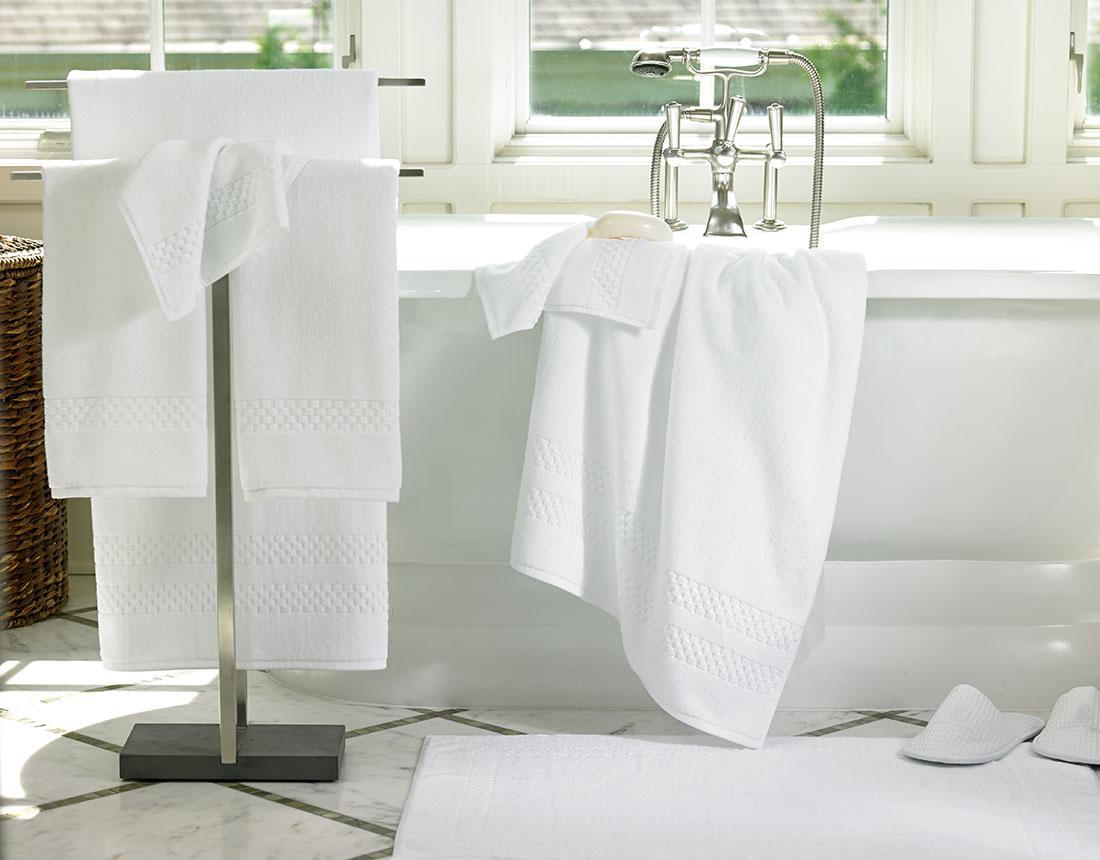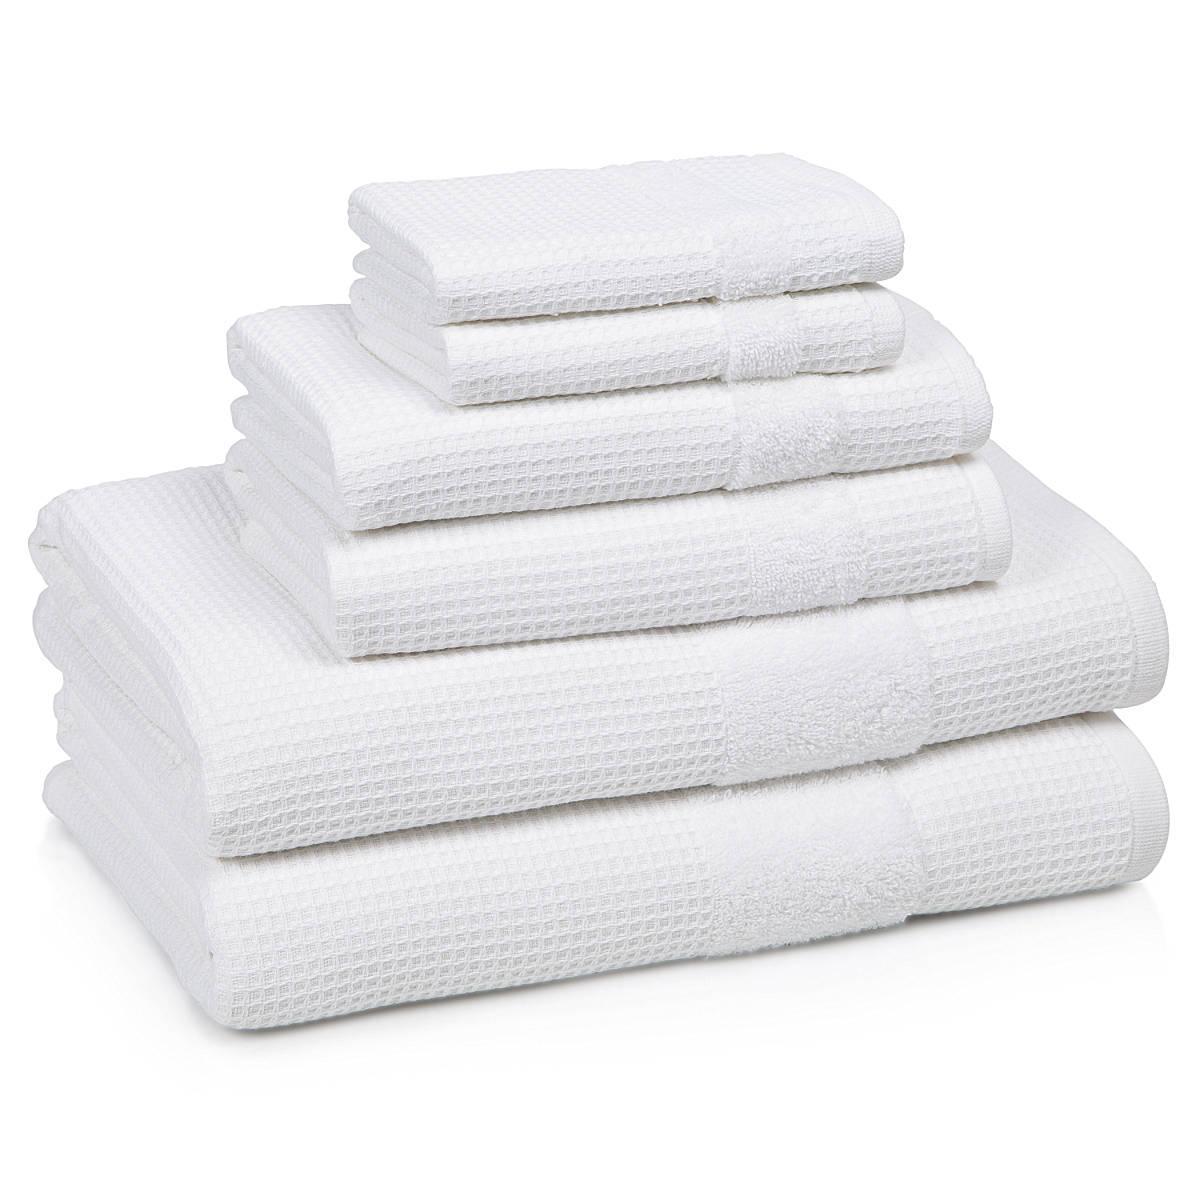The first image is the image on the left, the second image is the image on the right. For the images displayed, is the sentence "There are exactly six folded items in the image on the right." factually correct? Answer yes or no. Yes. 